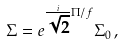<formula> <loc_0><loc_0><loc_500><loc_500>\Sigma = e ^ { \frac { i } { \sqrt { 2 } } \Pi / f } \Sigma _ { 0 } \, ,</formula> 